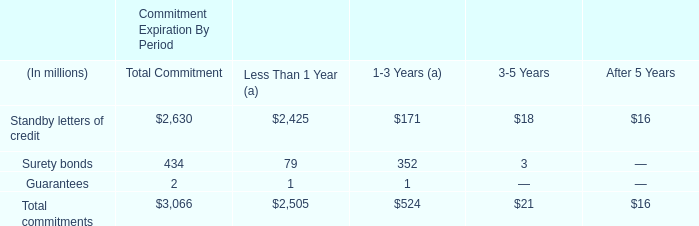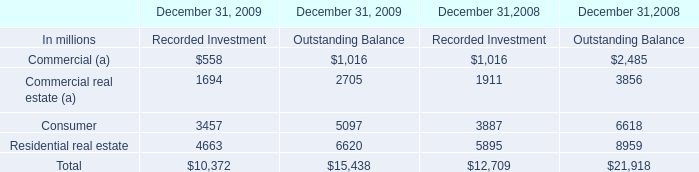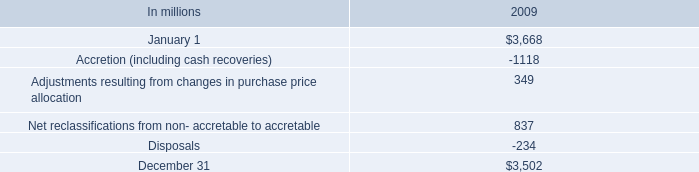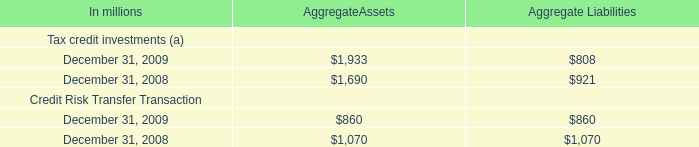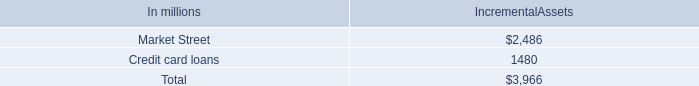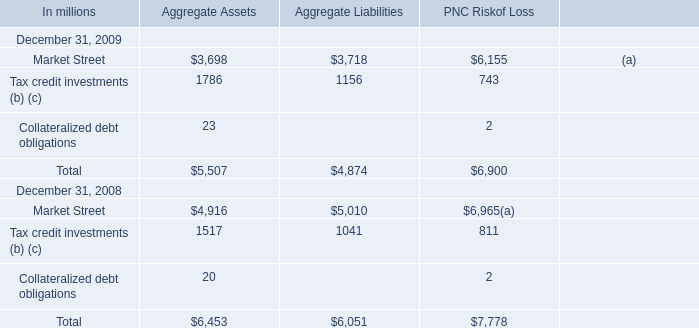What was the average value of the AggregateAssets in the years where AggregateAssets is positive? (in million) 
Computations: ((((1933 + 1690) + 860) + 1070) / 2)
Answer: 2776.5. 